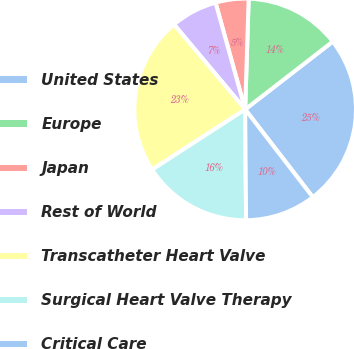<chart> <loc_0><loc_0><loc_500><loc_500><pie_chart><fcel>United States<fcel>Europe<fcel>Japan<fcel>Rest of World<fcel>Transcatheter Heart Valve<fcel>Surgical Heart Valve Therapy<fcel>Critical Care<nl><fcel>25.03%<fcel>14.01%<fcel>4.81%<fcel>6.79%<fcel>23.05%<fcel>15.99%<fcel>10.32%<nl></chart> 